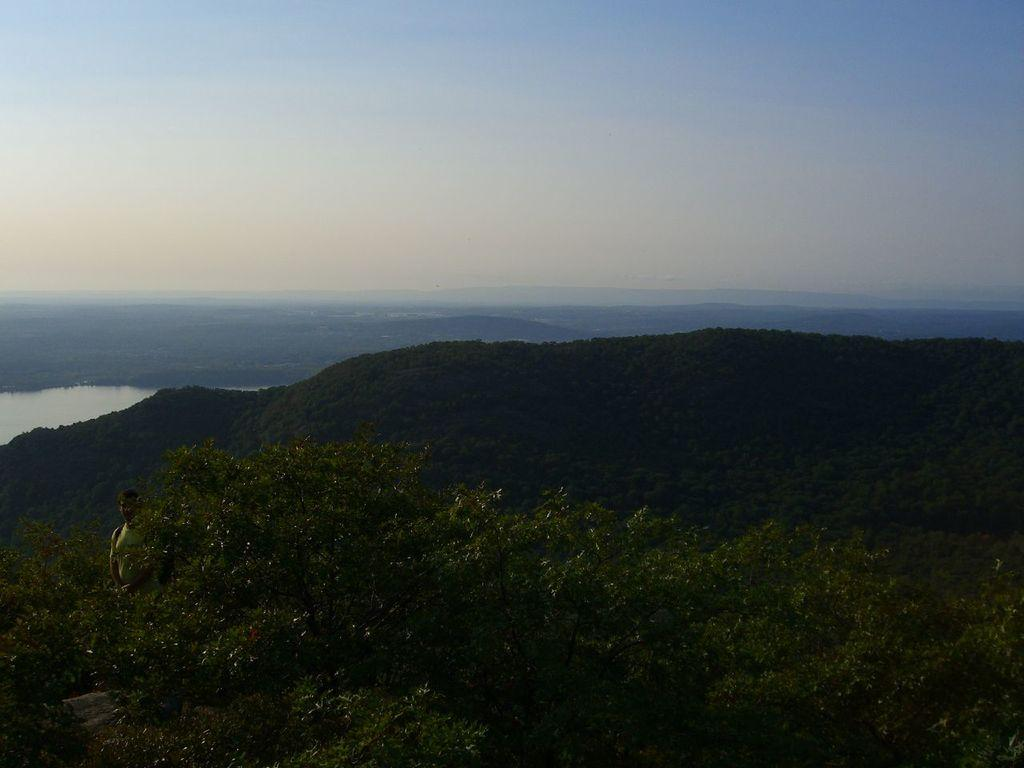What type of vegetation can be seen in the image? There are trees in the image. Can you describe the person in the image? There is a person standing in the image. What geographical feature is present in the image? There is a mountain in the image. What natural element is visible in the background of the image? The background of the image includes water. What part of the natural environment is visible in the image? The ground is visible in the background of the image. What part of the sky is visible in the image? The sky is visible in the background of the image. Where is the girl sitting with a cabbage in the image? There is no girl or cabbage present in the image. What type of poison is visible in the image? There is no poison present in the image. 